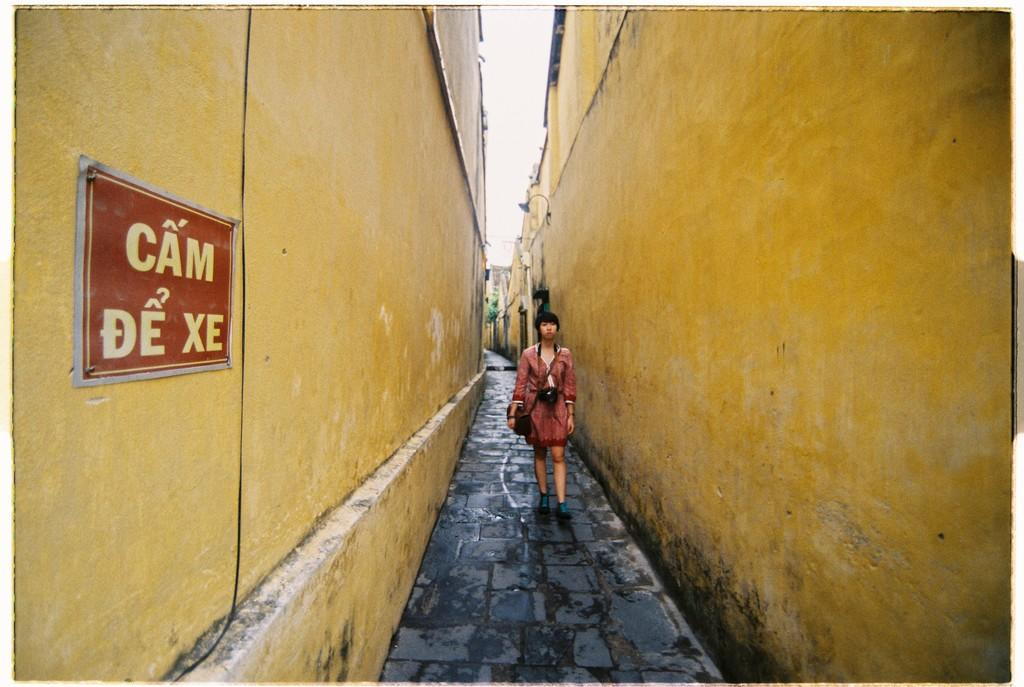<image>
Share a concise interpretation of the image provided. A woman walking down a long ally way with yellow walls and a red sign that reads cam de xe. 